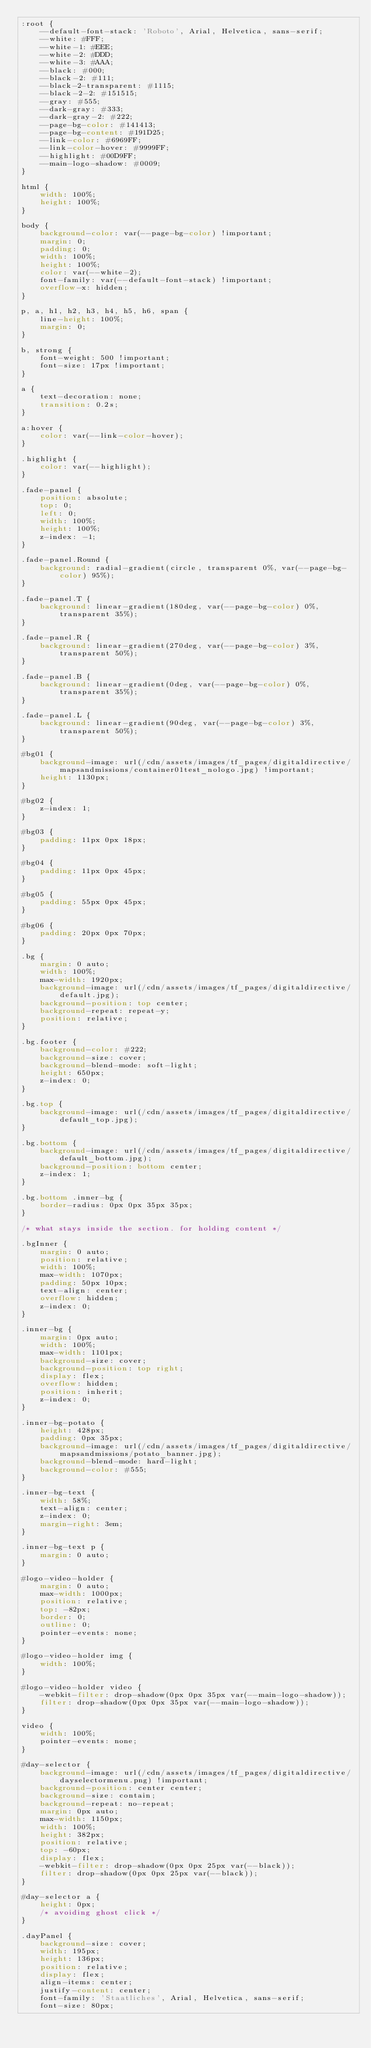Convert code to text. <code><loc_0><loc_0><loc_500><loc_500><_CSS_>:root {
    --default-font-stack: 'Roboto', Arial, Helvetica, sans-serif;
    --white: #FFF;
    --white-1: #EEE;
    --white-2: #DDD;
    --white-3: #AAA;
    --black: #000;
    --black-2: #111;
    --black-2-transparent: #1115;
    --black-2-2: #151515;
    --gray: #555;
    --dark-gray: #333;
    --dark-gray-2: #222;
    --page-bg-color: #141413;
    --page-bg-content: #191D25;
    --link-color: #6969FF;
    --link-color-hover: #9999FF;
    --highlight: #00D9FF;
    --main-logo-shadow: #0009;
}

html {
    width: 100%;
    height: 100%;
}

body {
    background-color: var(--page-bg-color) !important;
    margin: 0;
    padding: 0;
    width: 100%;
    height: 100%;
    color: var(--white-2);
    font-family: var(--default-font-stack) !important;
    overflow-x: hidden;
}

p, a, h1, h2, h3, h4, h5, h6, span {
    line-height: 100%;
    margin: 0;
}

b, strong {
    font-weight: 500 !important;
    font-size: 17px !important;
}

a {
    text-decoration: none;
    transition: 0.2s;
}

a:hover {
    color: var(--link-color-hover);
}

.highlight {
    color: var(--highlight);
}

.fade-panel {
    position: absolute;
    top: 0;
    left: 0;
    width: 100%;
    height: 100%;
    z-index: -1;
}

.fade-panel.Round {
    background: radial-gradient(circle, transparent 0%, var(--page-bg-color) 95%);
}

.fade-panel.T {
    background: linear-gradient(180deg, var(--page-bg-color) 0%, transparent 35%);
}

.fade-panel.R {
    background: linear-gradient(270deg, var(--page-bg-color) 3%, transparent 50%);
}

.fade-panel.B {
    background: linear-gradient(0deg, var(--page-bg-color) 0%, transparent 35%);
}

.fade-panel.L {
    background: linear-gradient(90deg, var(--page-bg-color) 3%, transparent 50%);
}

#bg01 {
    background-image: url(/cdn/assets/images/tf_pages/digitaldirective/mapsandmissions/container01test_nologo.jpg) !important;
    height: 1130px;
}

#bg02 {
    z-index: 1;
}

#bg03 {
    padding: 11px 0px 18px;
}

#bg04 {
    padding: 11px 0px 45px;
}

#bg05 {
    padding: 55px 0px 45px;
}

#bg06 {
    padding: 20px 0px 70px;
}

.bg {
    margin: 0 auto;
    width: 100%;
    max-width: 1920px;
    background-image: url(/cdn/assets/images/tf_pages/digitaldirective/default.jpg);
    background-position: top center;
    background-repeat: repeat-y;
    position: relative;
}

.bg.footer {
    background-color: #222;
    background-size: cover;
    background-blend-mode: soft-light;
    height: 650px;
    z-index: 0;
}

.bg.top {
    background-image: url(/cdn/assets/images/tf_pages/digitaldirective/default_top.jpg);
}

.bg.bottom {
    background-image: url(/cdn/assets/images/tf_pages/digitaldirective/default_bottom.jpg);
    background-position: bottom center;
    z-index: 1;
}

.bg.bottom .inner-bg {
    border-radius: 0px 0px 35px 35px;
}

/* what stays inside the section. for holding content */

.bgInner {
    margin: 0 auto;
    position: relative;
    width: 100%;
    max-width: 1070px;
    padding: 50px 10px;
    text-align: center;
    overflow: hidden;
    z-index: 0;
}

.inner-bg {
    margin: 0px auto;
    width: 100%;
    max-width: 1101px;
    background-size: cover;
    background-position: top right;
    display: flex;
    overflow: hidden;
    position: inherit;
    z-index: 0;
}

.inner-bg-potato {
    height: 428px;
    padding: 0px 35px;
    background-image: url(/cdn/assets/images/tf_pages/digitaldirective/mapsandmissions/potato_banner.jpg);
    background-blend-mode: hard-light;
    background-color: #555;
}

.inner-bg-text {
    width: 58%;
    text-align: center;
    z-index: 0;
    margin-right: 3em;
}

.inner-bg-text p {
    margin: 0 auto;
}

#logo-video-holder {
    margin: 0 auto;
    max-width: 1000px;
    position: relative;
    top: -82px;
    border: 0;
    outline: 0;
    pointer-events: none;
}

#logo-video-holder img {
    width: 100%;
}

#logo-video-holder video {
    -webkit-filter: drop-shadow(0px 0px 35px var(--main-logo-shadow));
    filter: drop-shadow(0px 0px 35px var(--main-logo-shadow));
}

video {
    width: 100%;
    pointer-events: none;
}

#day-selector {
    background-image: url(/cdn/assets/images/tf_pages/digitaldirective/dayselectormenu.png) !important;
    background-position: center center;
    background-size: contain;
    background-repeat: no-repeat;
    margin: 0px auto;
    max-width: 1150px;
    width: 100%;
    height: 382px;
    position: relative;
    top: -60px;
    display: flex;
    -webkit-filter: drop-shadow(0px 0px 25px var(--black));
    filter: drop-shadow(0px 0px 25px var(--black));
}

#day-selector a {
    height: 0px;
    /* avoiding ghost click */
}

.dayPanel {
    background-size: cover;
    width: 195px;
    height: 136px;
    position: relative;
    display: flex;
    align-items: center;
    justify-content: center;
    font-family: 'Staatliches', Arial, Helvetica, sans-serif;
    font-size: 80px;</code> 